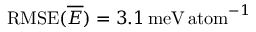<formula> <loc_0><loc_0><loc_500><loc_500>R M S E ( \overline { E } ) = 3 . 1 \, m e V \, a t o m ^ { - 1 }</formula> 